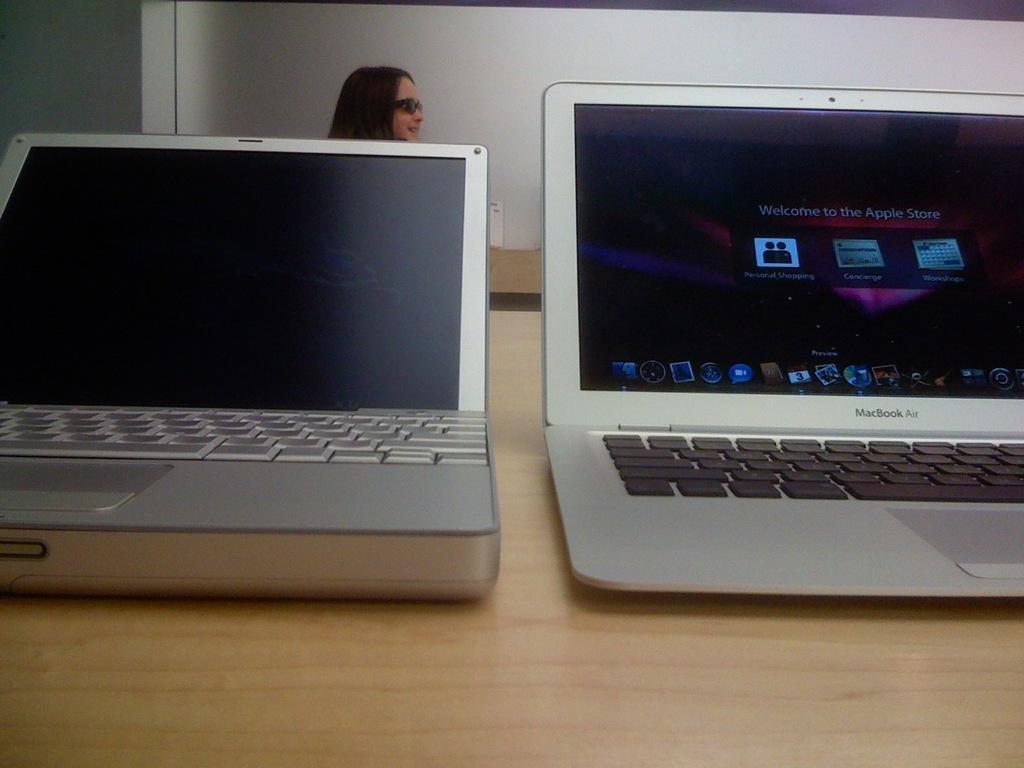Provide a one-sentence caption for the provided image. Macbook pro silver laptop with Welcome to the apple store screen. 